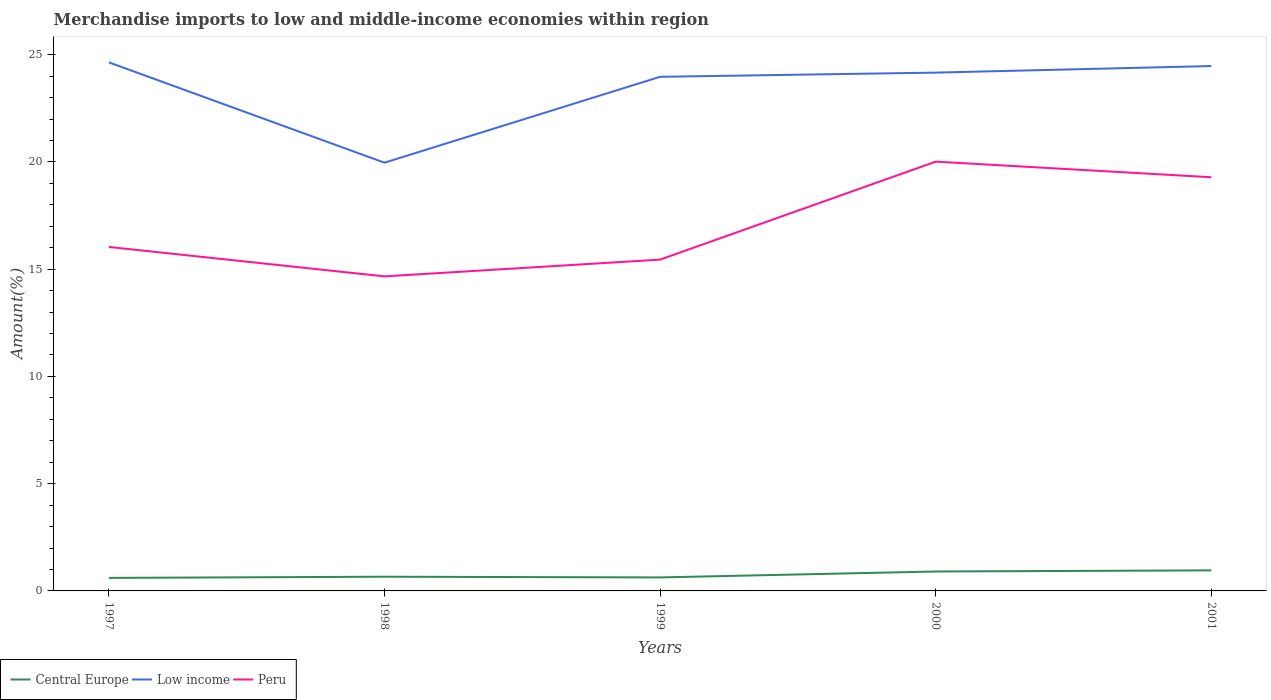Does the line corresponding to Central Europe intersect with the line corresponding to Peru?
Offer a very short reply. No. Is the number of lines equal to the number of legend labels?
Offer a terse response. Yes. Across all years, what is the maximum percentage of amount earned from merchandise imports in Peru?
Give a very brief answer. 14.66. In which year was the percentage of amount earned from merchandise imports in Central Europe maximum?
Your response must be concise. 1997. What is the total percentage of amount earned from merchandise imports in Low income in the graph?
Keep it short and to the point. 4.68. What is the difference between the highest and the second highest percentage of amount earned from merchandise imports in Low income?
Ensure brevity in your answer.  4.68. What is the difference between the highest and the lowest percentage of amount earned from merchandise imports in Low income?
Your response must be concise. 4. How many years are there in the graph?
Provide a short and direct response. 5. What is the difference between two consecutive major ticks on the Y-axis?
Your answer should be very brief. 5. Are the values on the major ticks of Y-axis written in scientific E-notation?
Provide a succinct answer. No. Does the graph contain any zero values?
Offer a terse response. No. Does the graph contain grids?
Provide a short and direct response. No. Where does the legend appear in the graph?
Offer a very short reply. Bottom left. What is the title of the graph?
Your response must be concise. Merchandise imports to low and middle-income economies within region. Does "Trinidad and Tobago" appear as one of the legend labels in the graph?
Ensure brevity in your answer.  No. What is the label or title of the Y-axis?
Provide a succinct answer. Amount(%). What is the Amount(%) of Central Europe in 1997?
Keep it short and to the point. 0.61. What is the Amount(%) in Low income in 1997?
Provide a succinct answer. 24.64. What is the Amount(%) in Peru in 1997?
Provide a short and direct response. 16.04. What is the Amount(%) of Central Europe in 1998?
Keep it short and to the point. 0.66. What is the Amount(%) in Low income in 1998?
Your answer should be compact. 19.96. What is the Amount(%) of Peru in 1998?
Keep it short and to the point. 14.66. What is the Amount(%) of Central Europe in 1999?
Provide a succinct answer. 0.63. What is the Amount(%) in Low income in 1999?
Your answer should be very brief. 23.97. What is the Amount(%) of Peru in 1999?
Your answer should be very brief. 15.45. What is the Amount(%) in Central Europe in 2000?
Make the answer very short. 0.91. What is the Amount(%) of Low income in 2000?
Ensure brevity in your answer.  24.16. What is the Amount(%) in Peru in 2000?
Make the answer very short. 20.01. What is the Amount(%) in Central Europe in 2001?
Provide a succinct answer. 0.96. What is the Amount(%) of Low income in 2001?
Keep it short and to the point. 24.47. What is the Amount(%) in Peru in 2001?
Provide a succinct answer. 19.29. Across all years, what is the maximum Amount(%) in Central Europe?
Offer a terse response. 0.96. Across all years, what is the maximum Amount(%) in Low income?
Give a very brief answer. 24.64. Across all years, what is the maximum Amount(%) in Peru?
Your answer should be very brief. 20.01. Across all years, what is the minimum Amount(%) in Central Europe?
Provide a succinct answer. 0.61. Across all years, what is the minimum Amount(%) in Low income?
Provide a succinct answer. 19.96. Across all years, what is the minimum Amount(%) in Peru?
Your answer should be very brief. 14.66. What is the total Amount(%) in Central Europe in the graph?
Make the answer very short. 3.76. What is the total Amount(%) of Low income in the graph?
Make the answer very short. 117.21. What is the total Amount(%) of Peru in the graph?
Make the answer very short. 85.44. What is the difference between the Amount(%) of Central Europe in 1997 and that in 1998?
Provide a succinct answer. -0.05. What is the difference between the Amount(%) of Low income in 1997 and that in 1998?
Give a very brief answer. 4.68. What is the difference between the Amount(%) of Peru in 1997 and that in 1998?
Your answer should be compact. 1.37. What is the difference between the Amount(%) of Central Europe in 1997 and that in 1999?
Your answer should be compact. -0.02. What is the difference between the Amount(%) in Low income in 1997 and that in 1999?
Offer a very short reply. 0.67. What is the difference between the Amount(%) of Peru in 1997 and that in 1999?
Keep it short and to the point. 0.59. What is the difference between the Amount(%) in Central Europe in 1997 and that in 2000?
Make the answer very short. -0.3. What is the difference between the Amount(%) of Low income in 1997 and that in 2000?
Your answer should be compact. 0.48. What is the difference between the Amount(%) of Peru in 1997 and that in 2000?
Offer a terse response. -3.98. What is the difference between the Amount(%) of Central Europe in 1997 and that in 2001?
Ensure brevity in your answer.  -0.35. What is the difference between the Amount(%) of Low income in 1997 and that in 2001?
Your answer should be very brief. 0.17. What is the difference between the Amount(%) of Peru in 1997 and that in 2001?
Offer a terse response. -3.25. What is the difference between the Amount(%) of Central Europe in 1998 and that in 1999?
Your answer should be very brief. 0.03. What is the difference between the Amount(%) of Low income in 1998 and that in 1999?
Provide a short and direct response. -4. What is the difference between the Amount(%) in Peru in 1998 and that in 1999?
Offer a very short reply. -0.78. What is the difference between the Amount(%) in Central Europe in 1998 and that in 2000?
Make the answer very short. -0.24. What is the difference between the Amount(%) in Low income in 1998 and that in 2000?
Provide a short and direct response. -4.2. What is the difference between the Amount(%) of Peru in 1998 and that in 2000?
Offer a very short reply. -5.35. What is the difference between the Amount(%) in Central Europe in 1998 and that in 2001?
Ensure brevity in your answer.  -0.3. What is the difference between the Amount(%) in Low income in 1998 and that in 2001?
Your response must be concise. -4.51. What is the difference between the Amount(%) in Peru in 1998 and that in 2001?
Keep it short and to the point. -4.62. What is the difference between the Amount(%) in Central Europe in 1999 and that in 2000?
Provide a succinct answer. -0.28. What is the difference between the Amount(%) in Low income in 1999 and that in 2000?
Ensure brevity in your answer.  -0.2. What is the difference between the Amount(%) in Peru in 1999 and that in 2000?
Keep it short and to the point. -4.57. What is the difference between the Amount(%) of Central Europe in 1999 and that in 2001?
Offer a terse response. -0.33. What is the difference between the Amount(%) in Low income in 1999 and that in 2001?
Keep it short and to the point. -0.5. What is the difference between the Amount(%) in Peru in 1999 and that in 2001?
Your answer should be compact. -3.84. What is the difference between the Amount(%) in Central Europe in 2000 and that in 2001?
Make the answer very short. -0.05. What is the difference between the Amount(%) in Low income in 2000 and that in 2001?
Your answer should be very brief. -0.31. What is the difference between the Amount(%) of Peru in 2000 and that in 2001?
Your answer should be very brief. 0.73. What is the difference between the Amount(%) of Central Europe in 1997 and the Amount(%) of Low income in 1998?
Ensure brevity in your answer.  -19.36. What is the difference between the Amount(%) of Central Europe in 1997 and the Amount(%) of Peru in 1998?
Keep it short and to the point. -14.06. What is the difference between the Amount(%) in Low income in 1997 and the Amount(%) in Peru in 1998?
Give a very brief answer. 9.98. What is the difference between the Amount(%) of Central Europe in 1997 and the Amount(%) of Low income in 1999?
Ensure brevity in your answer.  -23.36. What is the difference between the Amount(%) in Central Europe in 1997 and the Amount(%) in Peru in 1999?
Provide a short and direct response. -14.84. What is the difference between the Amount(%) of Low income in 1997 and the Amount(%) of Peru in 1999?
Offer a terse response. 9.2. What is the difference between the Amount(%) in Central Europe in 1997 and the Amount(%) in Low income in 2000?
Offer a terse response. -23.56. What is the difference between the Amount(%) in Central Europe in 1997 and the Amount(%) in Peru in 2000?
Keep it short and to the point. -19.41. What is the difference between the Amount(%) in Low income in 1997 and the Amount(%) in Peru in 2000?
Keep it short and to the point. 4.63. What is the difference between the Amount(%) in Central Europe in 1997 and the Amount(%) in Low income in 2001?
Your response must be concise. -23.86. What is the difference between the Amount(%) of Central Europe in 1997 and the Amount(%) of Peru in 2001?
Give a very brief answer. -18.68. What is the difference between the Amount(%) in Low income in 1997 and the Amount(%) in Peru in 2001?
Make the answer very short. 5.36. What is the difference between the Amount(%) of Central Europe in 1998 and the Amount(%) of Low income in 1999?
Provide a succinct answer. -23.31. What is the difference between the Amount(%) in Central Europe in 1998 and the Amount(%) in Peru in 1999?
Provide a succinct answer. -14.78. What is the difference between the Amount(%) in Low income in 1998 and the Amount(%) in Peru in 1999?
Provide a succinct answer. 4.52. What is the difference between the Amount(%) in Central Europe in 1998 and the Amount(%) in Low income in 2000?
Give a very brief answer. -23.5. What is the difference between the Amount(%) of Central Europe in 1998 and the Amount(%) of Peru in 2000?
Ensure brevity in your answer.  -19.35. What is the difference between the Amount(%) in Low income in 1998 and the Amount(%) in Peru in 2000?
Ensure brevity in your answer.  -0.05. What is the difference between the Amount(%) of Central Europe in 1998 and the Amount(%) of Low income in 2001?
Make the answer very short. -23.81. What is the difference between the Amount(%) of Central Europe in 1998 and the Amount(%) of Peru in 2001?
Ensure brevity in your answer.  -18.62. What is the difference between the Amount(%) of Low income in 1998 and the Amount(%) of Peru in 2001?
Provide a short and direct response. 0.68. What is the difference between the Amount(%) of Central Europe in 1999 and the Amount(%) of Low income in 2000?
Provide a short and direct response. -23.53. What is the difference between the Amount(%) in Central Europe in 1999 and the Amount(%) in Peru in 2000?
Make the answer very short. -19.38. What is the difference between the Amount(%) in Low income in 1999 and the Amount(%) in Peru in 2000?
Offer a very short reply. 3.96. What is the difference between the Amount(%) in Central Europe in 1999 and the Amount(%) in Low income in 2001?
Offer a terse response. -23.84. What is the difference between the Amount(%) in Central Europe in 1999 and the Amount(%) in Peru in 2001?
Your answer should be compact. -18.66. What is the difference between the Amount(%) of Low income in 1999 and the Amount(%) of Peru in 2001?
Make the answer very short. 4.68. What is the difference between the Amount(%) in Central Europe in 2000 and the Amount(%) in Low income in 2001?
Provide a succinct answer. -23.56. What is the difference between the Amount(%) in Central Europe in 2000 and the Amount(%) in Peru in 2001?
Keep it short and to the point. -18.38. What is the difference between the Amount(%) of Low income in 2000 and the Amount(%) of Peru in 2001?
Provide a short and direct response. 4.88. What is the average Amount(%) in Central Europe per year?
Your response must be concise. 0.75. What is the average Amount(%) of Low income per year?
Provide a short and direct response. 23.44. What is the average Amount(%) in Peru per year?
Provide a short and direct response. 17.09. In the year 1997, what is the difference between the Amount(%) of Central Europe and Amount(%) of Low income?
Make the answer very short. -24.03. In the year 1997, what is the difference between the Amount(%) in Central Europe and Amount(%) in Peru?
Your answer should be very brief. -15.43. In the year 1997, what is the difference between the Amount(%) of Low income and Amount(%) of Peru?
Provide a short and direct response. 8.61. In the year 1998, what is the difference between the Amount(%) of Central Europe and Amount(%) of Low income?
Give a very brief answer. -19.3. In the year 1998, what is the difference between the Amount(%) in Central Europe and Amount(%) in Peru?
Offer a terse response. -14. In the year 1998, what is the difference between the Amount(%) in Low income and Amount(%) in Peru?
Your response must be concise. 5.3. In the year 1999, what is the difference between the Amount(%) in Central Europe and Amount(%) in Low income?
Your answer should be very brief. -23.34. In the year 1999, what is the difference between the Amount(%) of Central Europe and Amount(%) of Peru?
Offer a very short reply. -14.82. In the year 1999, what is the difference between the Amount(%) of Low income and Amount(%) of Peru?
Your response must be concise. 8.52. In the year 2000, what is the difference between the Amount(%) in Central Europe and Amount(%) in Low income?
Keep it short and to the point. -23.26. In the year 2000, what is the difference between the Amount(%) of Central Europe and Amount(%) of Peru?
Your answer should be compact. -19.11. In the year 2000, what is the difference between the Amount(%) in Low income and Amount(%) in Peru?
Your answer should be compact. 4.15. In the year 2001, what is the difference between the Amount(%) in Central Europe and Amount(%) in Low income?
Give a very brief answer. -23.51. In the year 2001, what is the difference between the Amount(%) of Central Europe and Amount(%) of Peru?
Keep it short and to the point. -18.33. In the year 2001, what is the difference between the Amount(%) of Low income and Amount(%) of Peru?
Your answer should be compact. 5.18. What is the ratio of the Amount(%) in Central Europe in 1997 to that in 1998?
Provide a short and direct response. 0.92. What is the ratio of the Amount(%) in Low income in 1997 to that in 1998?
Keep it short and to the point. 1.23. What is the ratio of the Amount(%) of Peru in 1997 to that in 1998?
Your answer should be very brief. 1.09. What is the ratio of the Amount(%) of Central Europe in 1997 to that in 1999?
Offer a very short reply. 0.97. What is the ratio of the Amount(%) in Low income in 1997 to that in 1999?
Your answer should be very brief. 1.03. What is the ratio of the Amount(%) of Peru in 1997 to that in 1999?
Give a very brief answer. 1.04. What is the ratio of the Amount(%) of Central Europe in 1997 to that in 2000?
Provide a succinct answer. 0.67. What is the ratio of the Amount(%) of Low income in 1997 to that in 2000?
Ensure brevity in your answer.  1.02. What is the ratio of the Amount(%) of Peru in 1997 to that in 2000?
Offer a very short reply. 0.8. What is the ratio of the Amount(%) in Central Europe in 1997 to that in 2001?
Keep it short and to the point. 0.63. What is the ratio of the Amount(%) of Low income in 1997 to that in 2001?
Your response must be concise. 1.01. What is the ratio of the Amount(%) of Peru in 1997 to that in 2001?
Offer a terse response. 0.83. What is the ratio of the Amount(%) of Central Europe in 1998 to that in 1999?
Provide a succinct answer. 1.05. What is the ratio of the Amount(%) of Low income in 1998 to that in 1999?
Your answer should be very brief. 0.83. What is the ratio of the Amount(%) of Peru in 1998 to that in 1999?
Offer a terse response. 0.95. What is the ratio of the Amount(%) of Central Europe in 1998 to that in 2000?
Offer a terse response. 0.73. What is the ratio of the Amount(%) in Low income in 1998 to that in 2000?
Offer a very short reply. 0.83. What is the ratio of the Amount(%) in Peru in 1998 to that in 2000?
Offer a very short reply. 0.73. What is the ratio of the Amount(%) in Central Europe in 1998 to that in 2001?
Provide a succinct answer. 0.69. What is the ratio of the Amount(%) in Low income in 1998 to that in 2001?
Your response must be concise. 0.82. What is the ratio of the Amount(%) of Peru in 1998 to that in 2001?
Provide a short and direct response. 0.76. What is the ratio of the Amount(%) in Central Europe in 1999 to that in 2000?
Ensure brevity in your answer.  0.69. What is the ratio of the Amount(%) of Peru in 1999 to that in 2000?
Your answer should be compact. 0.77. What is the ratio of the Amount(%) in Central Europe in 1999 to that in 2001?
Make the answer very short. 0.66. What is the ratio of the Amount(%) of Low income in 1999 to that in 2001?
Your answer should be compact. 0.98. What is the ratio of the Amount(%) in Peru in 1999 to that in 2001?
Keep it short and to the point. 0.8. What is the ratio of the Amount(%) in Central Europe in 2000 to that in 2001?
Keep it short and to the point. 0.94. What is the ratio of the Amount(%) of Low income in 2000 to that in 2001?
Give a very brief answer. 0.99. What is the ratio of the Amount(%) of Peru in 2000 to that in 2001?
Ensure brevity in your answer.  1.04. What is the difference between the highest and the second highest Amount(%) in Central Europe?
Provide a short and direct response. 0.05. What is the difference between the highest and the second highest Amount(%) in Low income?
Give a very brief answer. 0.17. What is the difference between the highest and the second highest Amount(%) of Peru?
Your answer should be very brief. 0.73. What is the difference between the highest and the lowest Amount(%) in Central Europe?
Your answer should be very brief. 0.35. What is the difference between the highest and the lowest Amount(%) of Low income?
Offer a terse response. 4.68. What is the difference between the highest and the lowest Amount(%) in Peru?
Provide a short and direct response. 5.35. 